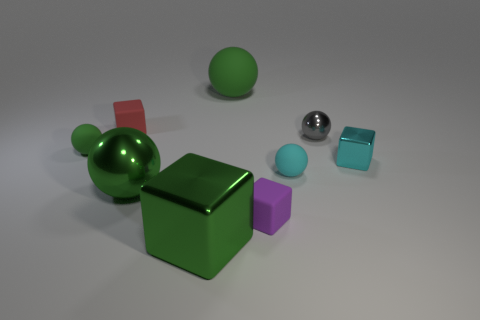There is a metal ball to the right of the tiny cyan sphere; does it have the same color as the small thing that is behind the gray metallic sphere? No, the metal ball located to the right of the tiny cyan sphere does not have the same color. The metal ball has a reflective silver color, while the small object hidden behind the gray metallic sphere appears to be a cube with a purple hue. The lighting in the scene emphasizes the metallic sheen of the sphere, which contrasts with the matte finish of the purple cube. 